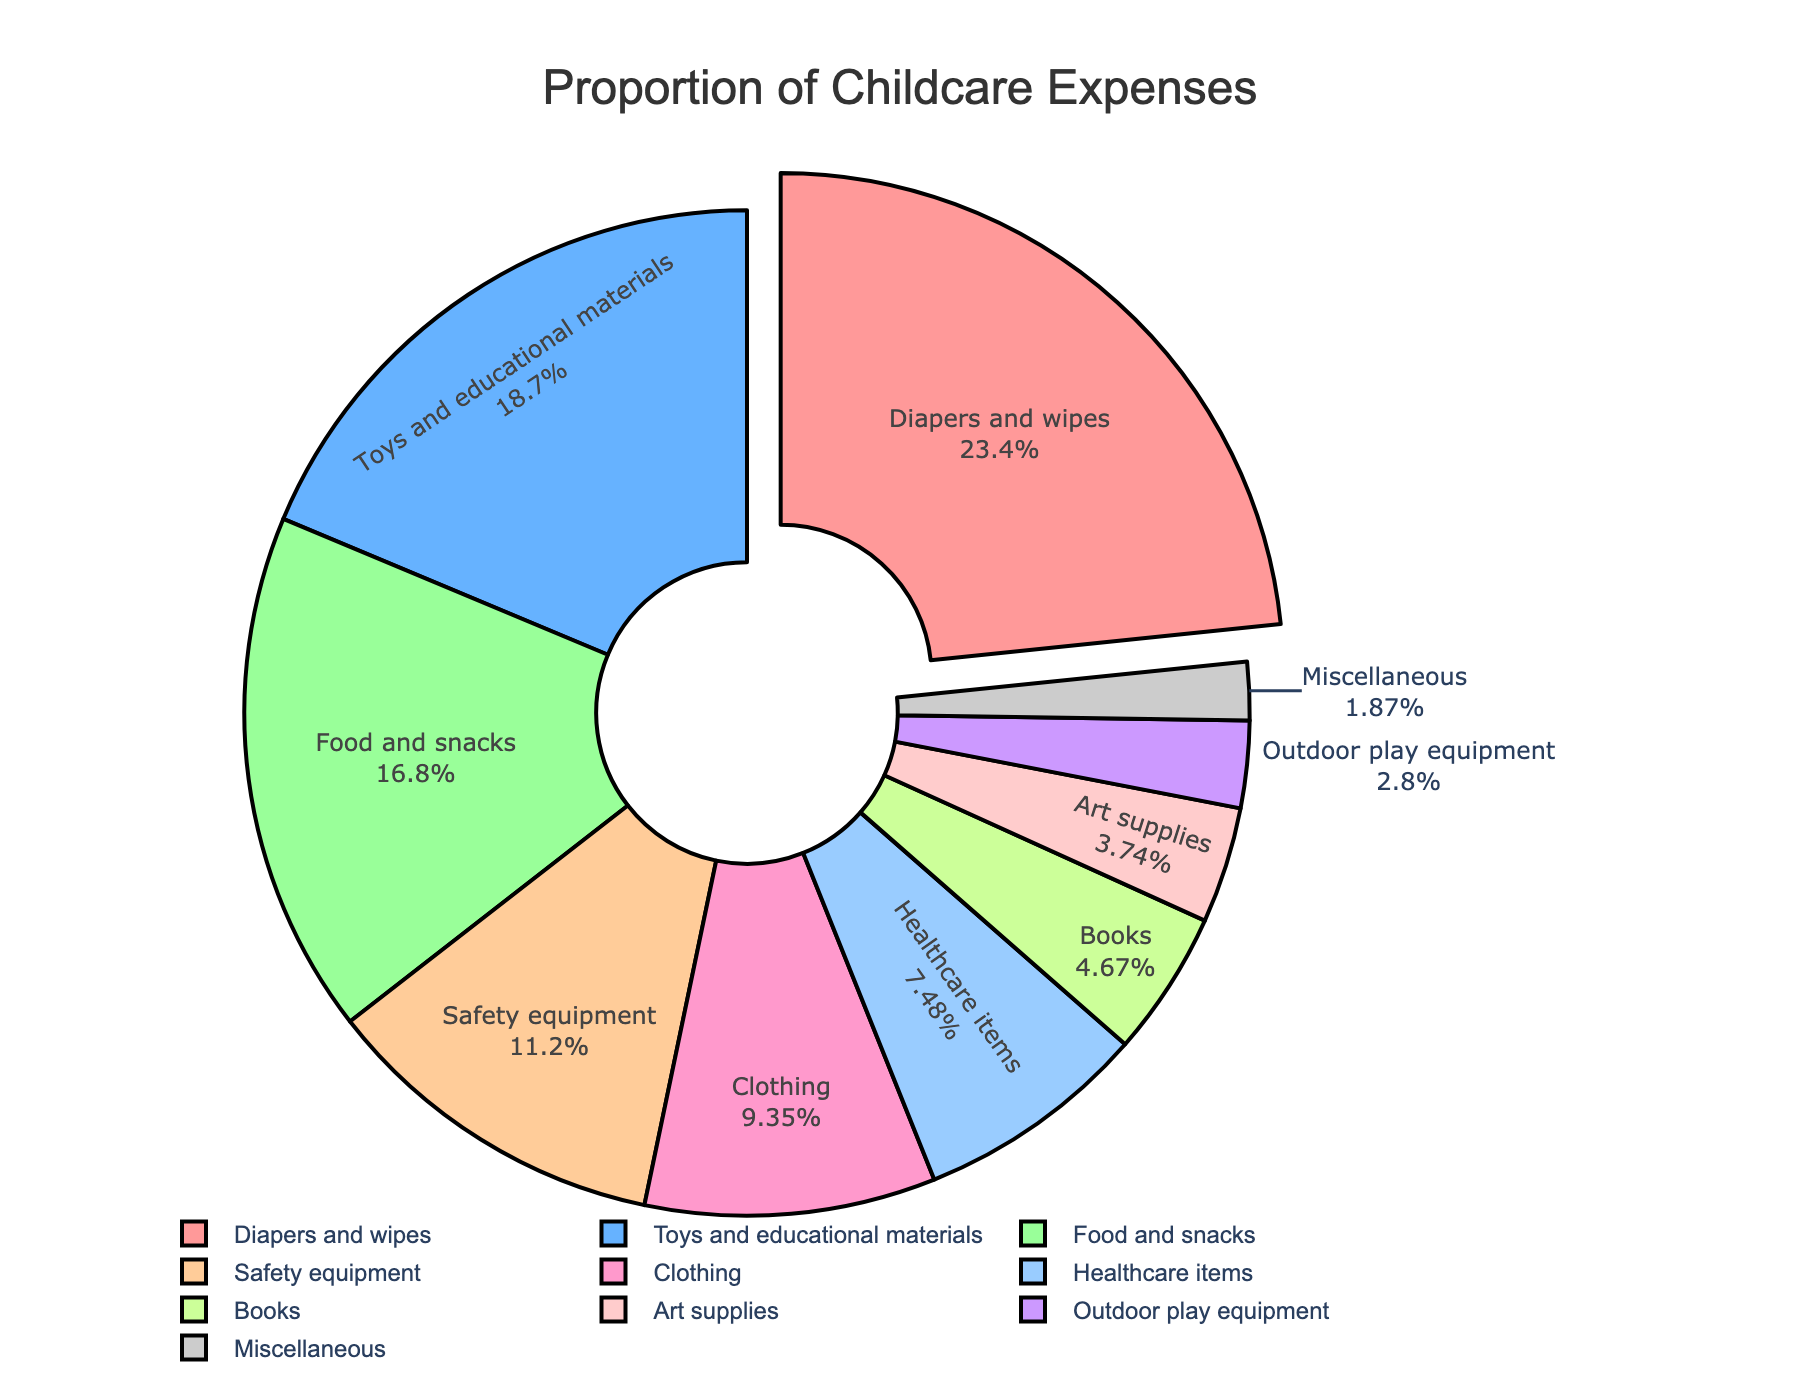what is the proportion of expenses for diapers and wipes? Look at the slice labeled "Diapers and wipes" in the pie chart and find the percentage shown.
Answer: 25% Which category has the smallest proportion of expenses? Find the smallest slice in the pie chart and check its label.
Answer: Miscellaneous How much is the combined proportion of food and snacks and healthcare items? Locate the percentages for "Food and snacks" and "Healthcare items" in the pie chart, then sum them up (18% + 8%).
Answer: 26% What category has a higher proportion of expenses, toys and educational materials or clothing? Locate the percentages for "Toys and educational materials" (20%) and "Clothing" (10%) in the pie chart and compare them.
Answer: Toys and educational materials Which categories together make up exactly 50% of expenses? Look for slices that together total exactly 50%. "Diapers and wipes" is 25% and "Toys and educational materials" is 20%, adding another small category, "Books" is 5%, giving a total of 25% + 20% + 5%.
Answer: Diapers and wipes, Toys and educational materials, Books What is the difference in proportion between safety equipment and art supplies? Find the percentages for "Safety equipment" (12%) and "Art supplies" (4%) in the pie chart and subtract the smaller from the larger (12% - 4%).
Answer: 8% Which category has the third largest proportion of expenses? Identify the three largest slices in the pie chart and find the label of the third one. The three largest are "Diapers and wipes" (25%), "Toys and educational materials" (20%), and "Food and snacks" (18%).
Answer: Food and snacks What is the total proportion of expenses for safety equipment, books, and outdoor play equipment combined? Sum up the proportions of "Safety equipment" (12%), "Books" (5%), and "Outdoor play equipment" (3%) shown in the pie chart (12% + 5% + 3%).
Answer: 20% Which category is represented by the pink slice? Locate the pink slice visually in the pie chart and read its label.
Answer: Diapers and wipes How does the proportion of expenses for clothing compare to healthcare items? Locate the percentages for "Clothing" (10%) and "Healthcare items" (8%) in the pie chart and compare them.
Answer: Clothing is higher 